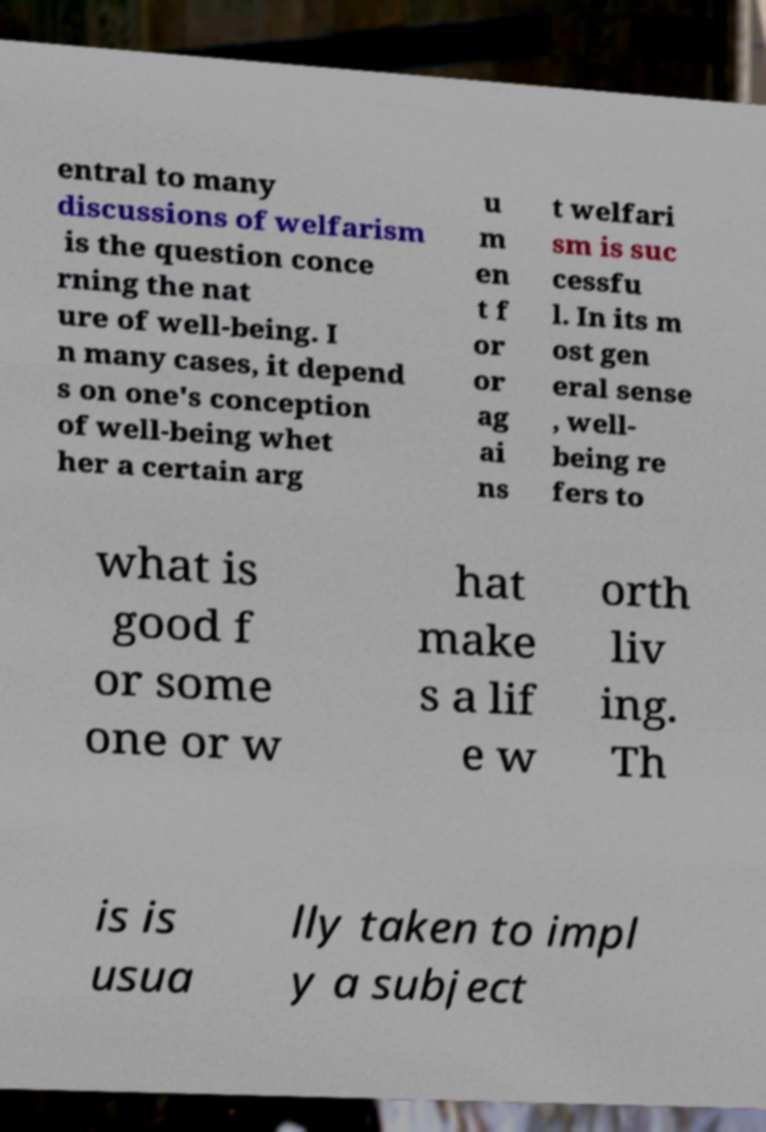There's text embedded in this image that I need extracted. Can you transcribe it verbatim? entral to many discussions of welfarism is the question conce rning the nat ure of well-being. I n many cases, it depend s on one's conception of well-being whet her a certain arg u m en t f or or ag ai ns t welfari sm is suc cessfu l. In its m ost gen eral sense , well- being re fers to what is good f or some one or w hat make s a lif e w orth liv ing. Th is is usua lly taken to impl y a subject 